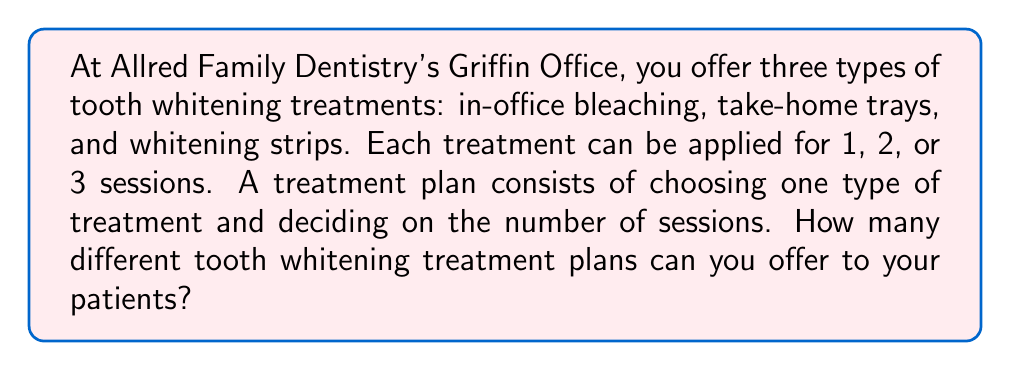Solve this math problem. Let's break this problem down step-by-step:

1) We have two choices to make for each treatment plan:
   a) The type of treatment
   b) The number of sessions

2) For the type of treatment, we have 3 options:
   - In-office bleaching
   - Take-home trays
   - Whitening strips

3) For the number of sessions, we have 3 options:
   - 1 session
   - 2 sessions
   - 3 sessions

4) This is a multiplication principle problem. For each type of treatment, we can choose any of the three session options.

5) We can represent this mathematically as:

   $$ \text{Total plans} = \text{Number of treatment types} \times \text{Number of session options} $$

6) Plugging in our values:

   $$ \text{Total plans} = 3 \times 3 = 9 $$

Therefore, there are 9 possible tooth whitening treatment plans that can be offered to patients.
Answer: $9$ possible tooth whitening treatment plans 